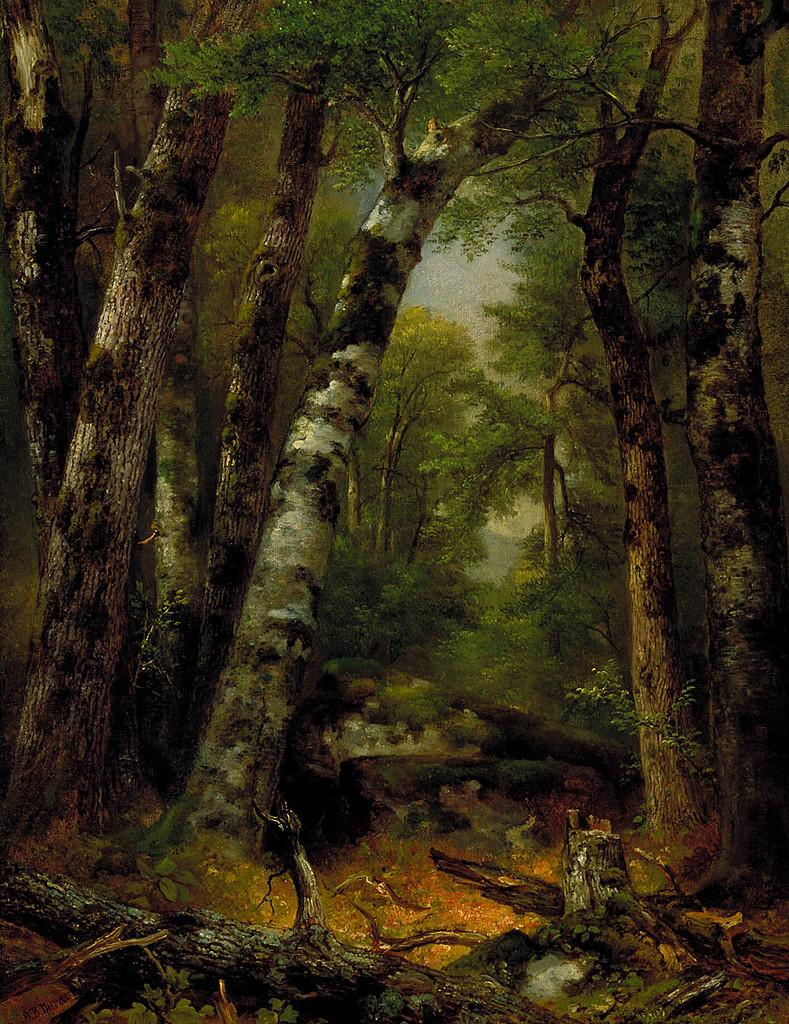What type of vegetation is present in the image? There are trees in the image. Can you describe the condition of the trees in the image? There are tree branches on the ground in the image, which suggests that some branches have fallen from the trees. What type of doctor is examining the trees in the image? There is no doctor present in the image, and the trees are not being examined by anyone. 